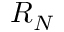Convert formula to latex. <formula><loc_0><loc_0><loc_500><loc_500>R _ { N }</formula> 